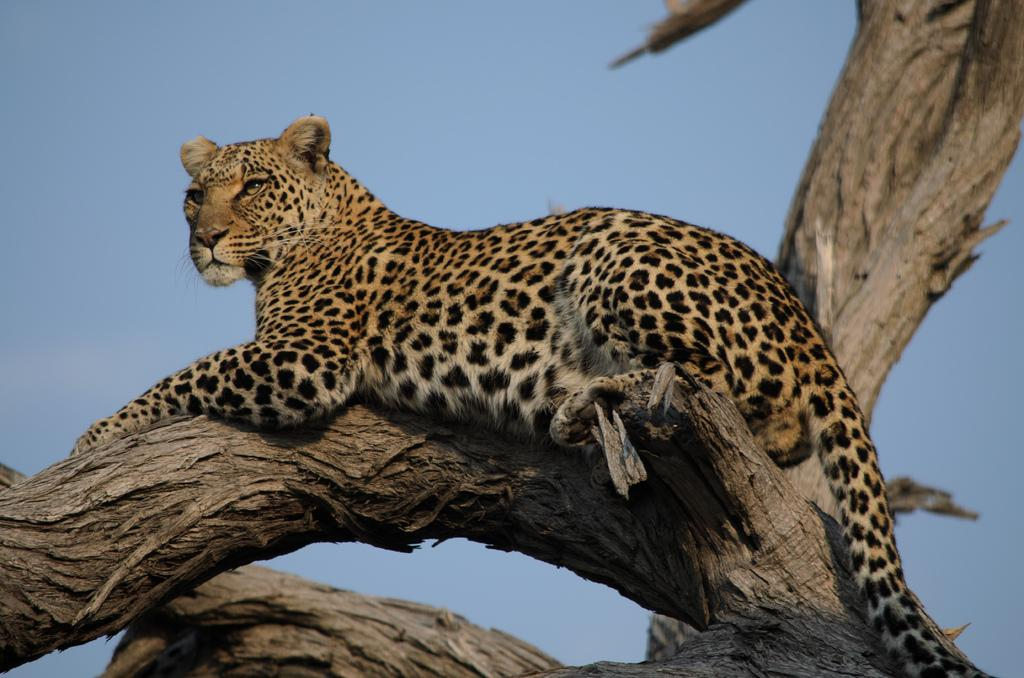What animal is present in the image? There is a leopard in the image. Where is the leopard located in the image? The leopard is on a tree. What can be seen in the background of the image? The sky is visible in the background of the image. What type of afterthought can be seen written on the paper in the image? There is no paper present in the image, so it is not possible to determine if there is any afterthought written on it. 